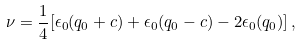Convert formula to latex. <formula><loc_0><loc_0><loc_500><loc_500>\nu = \frac { 1 } { 4 } [ \epsilon _ { 0 } ( q _ { 0 } + c ) + \epsilon _ { 0 } ( q _ { 0 } - c ) - 2 \epsilon _ { 0 } ( q _ { 0 } ) ] \, ,</formula> 